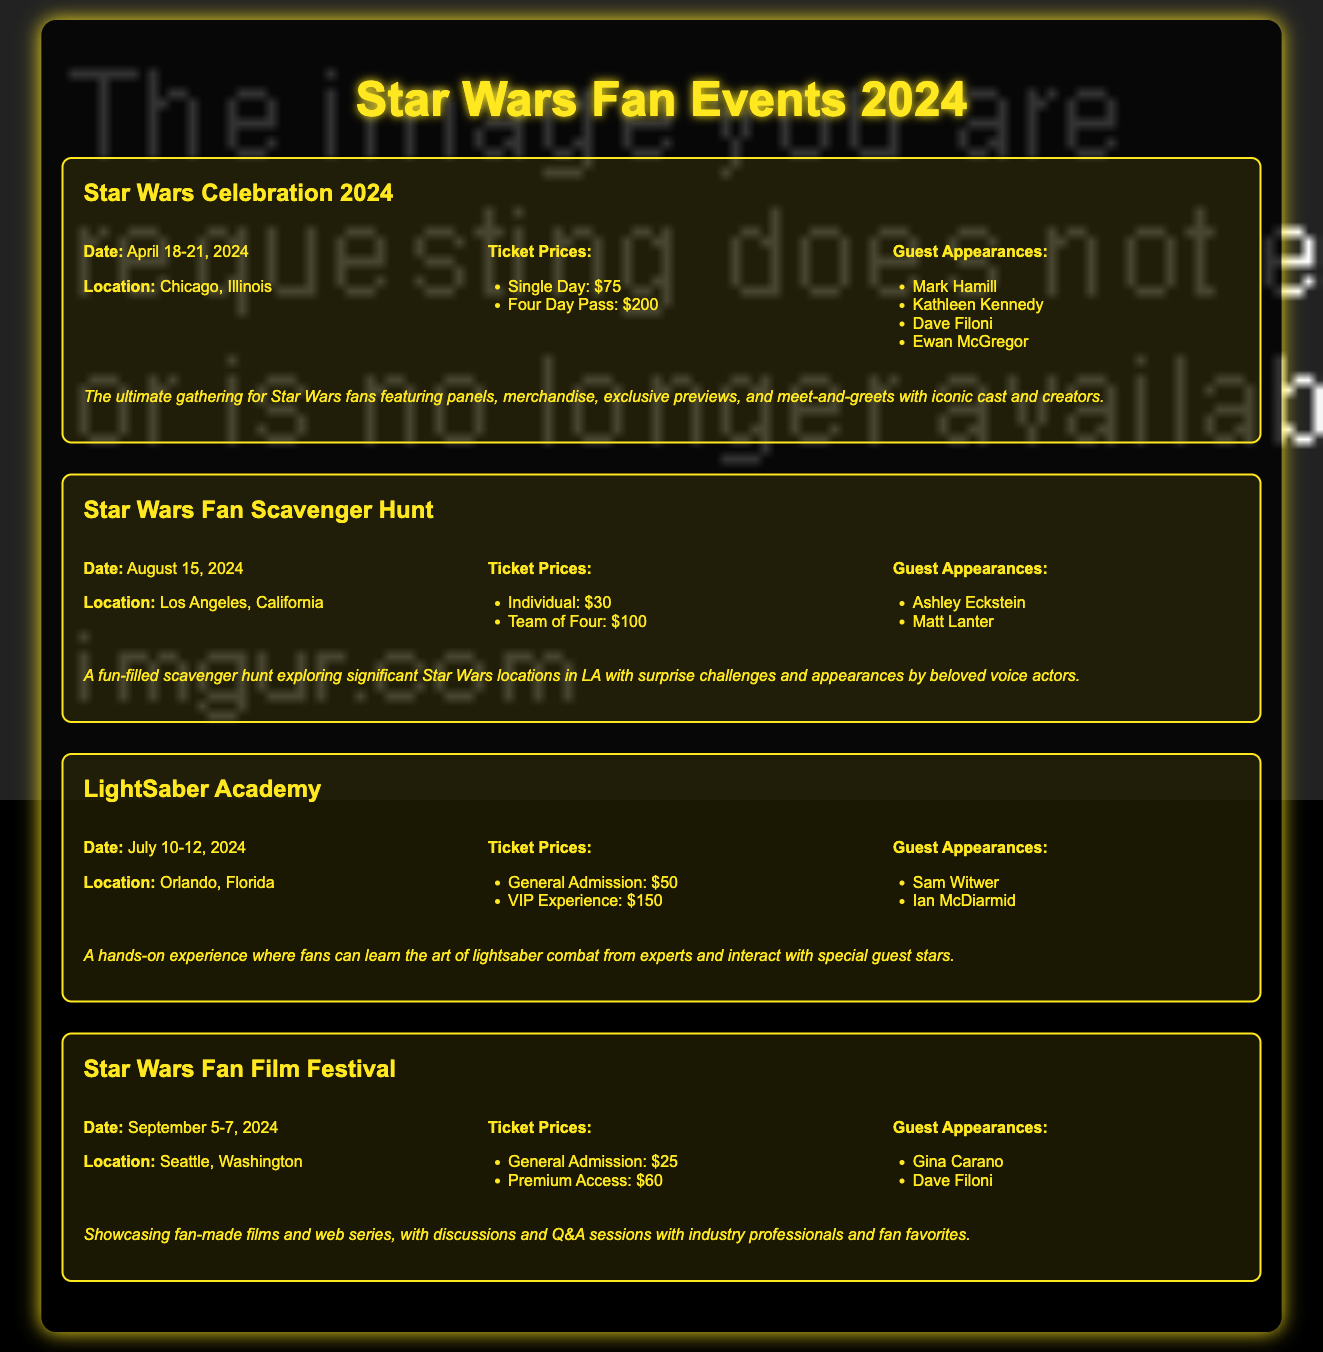what are the ticket prices for Star Wars Celebration 2024? The ticket prices are listed in the document for Star Wars Celebration 2024, which include Single Day: $75 and Four Day Pass: $200.
Answer: Single Day: $75, Four Day Pass: $200 who are the guest appearances at LightSaber Academy? The guest appearances for LightSaber Academy are provided in the event details, which include Sam Witwer and Ian McDiarmid.
Answer: Sam Witwer, Ian McDiarmid when is the Star Wars Fan Film Festival taking place? The document specifies the date for the Star Wars Fan Film Festival, which is September 5-7, 2024.
Answer: September 5-7, 2024 what is the location of the Star Wars Fan Scavenger Hunt? The location for the Star Wars Fan Scavenger Hunt is stated in the document, which is Los Angeles, California.
Answer: Los Angeles, California how much does a VIP Experience cost at LightSaber Academy? The document indicates the cost for the VIP Experience at LightSaber Academy, which is $150.
Answer: $150 which two guests are appearing at the Star Wars Fan Scavenger Hunt? The document lists the guest appearances for the event, which are Ashley Eckstein and Matt Lanter.
Answer: Ashley Eckstein, Matt Lanter what type of event is the Star Wars Celebration 2024? The document describes the type of event for Star Wars Celebration 2024 as "the ultimate gathering for Star Wars fans featuring panels, merchandise, exclusive previews, and meet-and-greets."
Answer: the ultimate gathering for Star Wars fans how many events are listed in the document? The document includes a count of events mentioned within it, which totals four events.
Answer: four events what is the ticket price for General Admission to the Star Wars Fan Film Festival? The ticket price for General Admission for the Star Wars Fan Film Festival is stated in the document as $25.
Answer: $25 